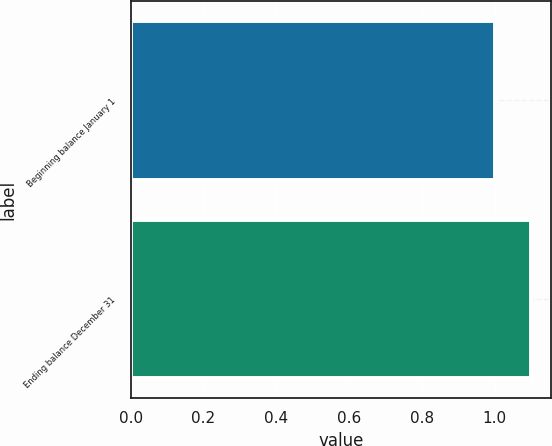Convert chart to OTSL. <chart><loc_0><loc_0><loc_500><loc_500><bar_chart><fcel>Beginning balance January 1<fcel>Ending balance December 31<nl><fcel>1<fcel>1.1<nl></chart> 